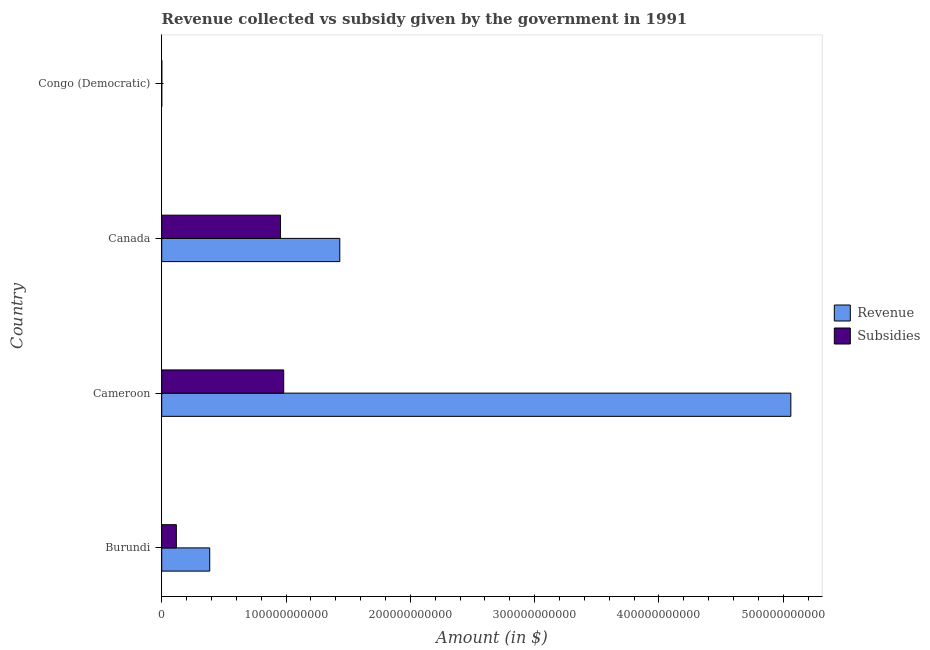Are the number of bars on each tick of the Y-axis equal?
Your response must be concise. Yes. How many bars are there on the 4th tick from the bottom?
Your response must be concise. 2. What is the label of the 4th group of bars from the top?
Make the answer very short. Burundi. In how many cases, is the number of bars for a given country not equal to the number of legend labels?
Provide a succinct answer. 0. What is the amount of revenue collected in Congo (Democratic)?
Provide a succinct answer. 23.51. Across all countries, what is the maximum amount of revenue collected?
Your response must be concise. 5.06e+11. Across all countries, what is the minimum amount of revenue collected?
Provide a short and direct response. 23.51. In which country was the amount of subsidies given maximum?
Give a very brief answer. Cameroon. In which country was the amount of revenue collected minimum?
Your answer should be very brief. Congo (Democratic). What is the total amount of subsidies given in the graph?
Ensure brevity in your answer.  2.06e+11. What is the difference between the amount of subsidies given in Burundi and that in Cameroon?
Keep it short and to the point. -8.64e+1. What is the difference between the amount of revenue collected in Congo (Democratic) and the amount of subsidies given in Canada?
Provide a succinct answer. -9.56e+1. What is the average amount of revenue collected per country?
Your answer should be compact. 1.72e+11. What is the difference between the amount of revenue collected and amount of subsidies given in Congo (Democratic)?
Your answer should be very brief. -7.05e+07. In how many countries, is the amount of revenue collected greater than 80000000000 $?
Ensure brevity in your answer.  2. What is the ratio of the amount of revenue collected in Burundi to that in Congo (Democratic)?
Keep it short and to the point. 1.64e+09. Is the difference between the amount of revenue collected in Burundi and Cameroon greater than the difference between the amount of subsidies given in Burundi and Cameroon?
Ensure brevity in your answer.  No. What is the difference between the highest and the second highest amount of revenue collected?
Ensure brevity in your answer.  3.63e+11. What is the difference between the highest and the lowest amount of revenue collected?
Your answer should be compact. 5.06e+11. Is the sum of the amount of revenue collected in Cameroon and Congo (Democratic) greater than the maximum amount of subsidies given across all countries?
Offer a very short reply. Yes. What does the 1st bar from the top in Cameroon represents?
Keep it short and to the point. Subsidies. What does the 2nd bar from the bottom in Burundi represents?
Provide a short and direct response. Subsidies. How many bars are there?
Provide a succinct answer. 8. Are all the bars in the graph horizontal?
Your answer should be very brief. Yes. What is the difference between two consecutive major ticks on the X-axis?
Offer a very short reply. 1.00e+11. Are the values on the major ticks of X-axis written in scientific E-notation?
Your response must be concise. No. Does the graph contain any zero values?
Your answer should be very brief. No. Where does the legend appear in the graph?
Your answer should be compact. Center right. What is the title of the graph?
Your answer should be very brief. Revenue collected vs subsidy given by the government in 1991. Does "Excluding technical cooperation" appear as one of the legend labels in the graph?
Your response must be concise. No. What is the label or title of the X-axis?
Your answer should be very brief. Amount (in $). What is the label or title of the Y-axis?
Provide a succinct answer. Country. What is the Amount (in $) in Revenue in Burundi?
Give a very brief answer. 3.86e+1. What is the Amount (in $) in Subsidies in Burundi?
Provide a short and direct response. 1.18e+1. What is the Amount (in $) in Revenue in Cameroon?
Offer a terse response. 5.06e+11. What is the Amount (in $) in Subsidies in Cameroon?
Provide a succinct answer. 9.82e+1. What is the Amount (in $) of Revenue in Canada?
Make the answer very short. 1.43e+11. What is the Amount (in $) in Subsidies in Canada?
Ensure brevity in your answer.  9.56e+1. What is the Amount (in $) in Revenue in Congo (Democratic)?
Provide a succinct answer. 23.51. What is the Amount (in $) of Subsidies in Congo (Democratic)?
Your response must be concise. 7.05e+07. Across all countries, what is the maximum Amount (in $) of Revenue?
Make the answer very short. 5.06e+11. Across all countries, what is the maximum Amount (in $) in Subsidies?
Keep it short and to the point. 9.82e+1. Across all countries, what is the minimum Amount (in $) in Revenue?
Keep it short and to the point. 23.51. Across all countries, what is the minimum Amount (in $) of Subsidies?
Keep it short and to the point. 7.05e+07. What is the total Amount (in $) of Revenue in the graph?
Provide a short and direct response. 6.88e+11. What is the total Amount (in $) of Subsidies in the graph?
Your answer should be compact. 2.06e+11. What is the difference between the Amount (in $) of Revenue in Burundi and that in Cameroon?
Offer a terse response. -4.68e+11. What is the difference between the Amount (in $) in Subsidies in Burundi and that in Cameroon?
Ensure brevity in your answer.  -8.64e+1. What is the difference between the Amount (in $) of Revenue in Burundi and that in Canada?
Give a very brief answer. -1.05e+11. What is the difference between the Amount (in $) of Subsidies in Burundi and that in Canada?
Ensure brevity in your answer.  -8.38e+1. What is the difference between the Amount (in $) of Revenue in Burundi and that in Congo (Democratic)?
Your answer should be compact. 3.86e+1. What is the difference between the Amount (in $) of Subsidies in Burundi and that in Congo (Democratic)?
Keep it short and to the point. 1.17e+1. What is the difference between the Amount (in $) in Revenue in Cameroon and that in Canada?
Make the answer very short. 3.63e+11. What is the difference between the Amount (in $) of Subsidies in Cameroon and that in Canada?
Your answer should be compact. 2.56e+09. What is the difference between the Amount (in $) of Revenue in Cameroon and that in Congo (Democratic)?
Ensure brevity in your answer.  5.06e+11. What is the difference between the Amount (in $) of Subsidies in Cameroon and that in Congo (Democratic)?
Give a very brief answer. 9.81e+1. What is the difference between the Amount (in $) in Revenue in Canada and that in Congo (Democratic)?
Provide a succinct answer. 1.43e+11. What is the difference between the Amount (in $) of Subsidies in Canada and that in Congo (Democratic)?
Your answer should be very brief. 9.55e+1. What is the difference between the Amount (in $) in Revenue in Burundi and the Amount (in $) in Subsidies in Cameroon?
Provide a succinct answer. -5.95e+1. What is the difference between the Amount (in $) of Revenue in Burundi and the Amount (in $) of Subsidies in Canada?
Give a very brief answer. -5.70e+1. What is the difference between the Amount (in $) in Revenue in Burundi and the Amount (in $) in Subsidies in Congo (Democratic)?
Ensure brevity in your answer.  3.86e+1. What is the difference between the Amount (in $) of Revenue in Cameroon and the Amount (in $) of Subsidies in Canada?
Provide a short and direct response. 4.11e+11. What is the difference between the Amount (in $) in Revenue in Cameroon and the Amount (in $) in Subsidies in Congo (Democratic)?
Your answer should be very brief. 5.06e+11. What is the difference between the Amount (in $) of Revenue in Canada and the Amount (in $) of Subsidies in Congo (Democratic)?
Make the answer very short. 1.43e+11. What is the average Amount (in $) in Revenue per country?
Provide a succinct answer. 1.72e+11. What is the average Amount (in $) in Subsidies per country?
Your answer should be very brief. 5.14e+1. What is the difference between the Amount (in $) of Revenue and Amount (in $) of Subsidies in Burundi?
Offer a terse response. 2.69e+1. What is the difference between the Amount (in $) of Revenue and Amount (in $) of Subsidies in Cameroon?
Make the answer very short. 4.08e+11. What is the difference between the Amount (in $) of Revenue and Amount (in $) of Subsidies in Canada?
Provide a succinct answer. 4.77e+1. What is the difference between the Amount (in $) in Revenue and Amount (in $) in Subsidies in Congo (Democratic)?
Your answer should be compact. -7.05e+07. What is the ratio of the Amount (in $) of Revenue in Burundi to that in Cameroon?
Make the answer very short. 0.08. What is the ratio of the Amount (in $) in Subsidies in Burundi to that in Cameroon?
Offer a very short reply. 0.12. What is the ratio of the Amount (in $) of Revenue in Burundi to that in Canada?
Your response must be concise. 0.27. What is the ratio of the Amount (in $) of Subsidies in Burundi to that in Canada?
Your answer should be compact. 0.12. What is the ratio of the Amount (in $) of Revenue in Burundi to that in Congo (Democratic)?
Make the answer very short. 1.64e+09. What is the ratio of the Amount (in $) in Subsidies in Burundi to that in Congo (Democratic)?
Your answer should be compact. 167.14. What is the ratio of the Amount (in $) of Revenue in Cameroon to that in Canada?
Give a very brief answer. 3.53. What is the ratio of the Amount (in $) of Subsidies in Cameroon to that in Canada?
Your answer should be compact. 1.03. What is the ratio of the Amount (in $) in Revenue in Cameroon to that in Congo (Democratic)?
Provide a succinct answer. 2.15e+1. What is the ratio of the Amount (in $) of Subsidies in Cameroon to that in Congo (Democratic)?
Your answer should be compact. 1391.8. What is the ratio of the Amount (in $) in Revenue in Canada to that in Congo (Democratic)?
Provide a succinct answer. 6.09e+09. What is the ratio of the Amount (in $) in Subsidies in Canada to that in Congo (Democratic)?
Your answer should be compact. 1355.47. What is the difference between the highest and the second highest Amount (in $) in Revenue?
Your answer should be compact. 3.63e+11. What is the difference between the highest and the second highest Amount (in $) in Subsidies?
Your answer should be very brief. 2.56e+09. What is the difference between the highest and the lowest Amount (in $) in Revenue?
Ensure brevity in your answer.  5.06e+11. What is the difference between the highest and the lowest Amount (in $) of Subsidies?
Provide a succinct answer. 9.81e+1. 